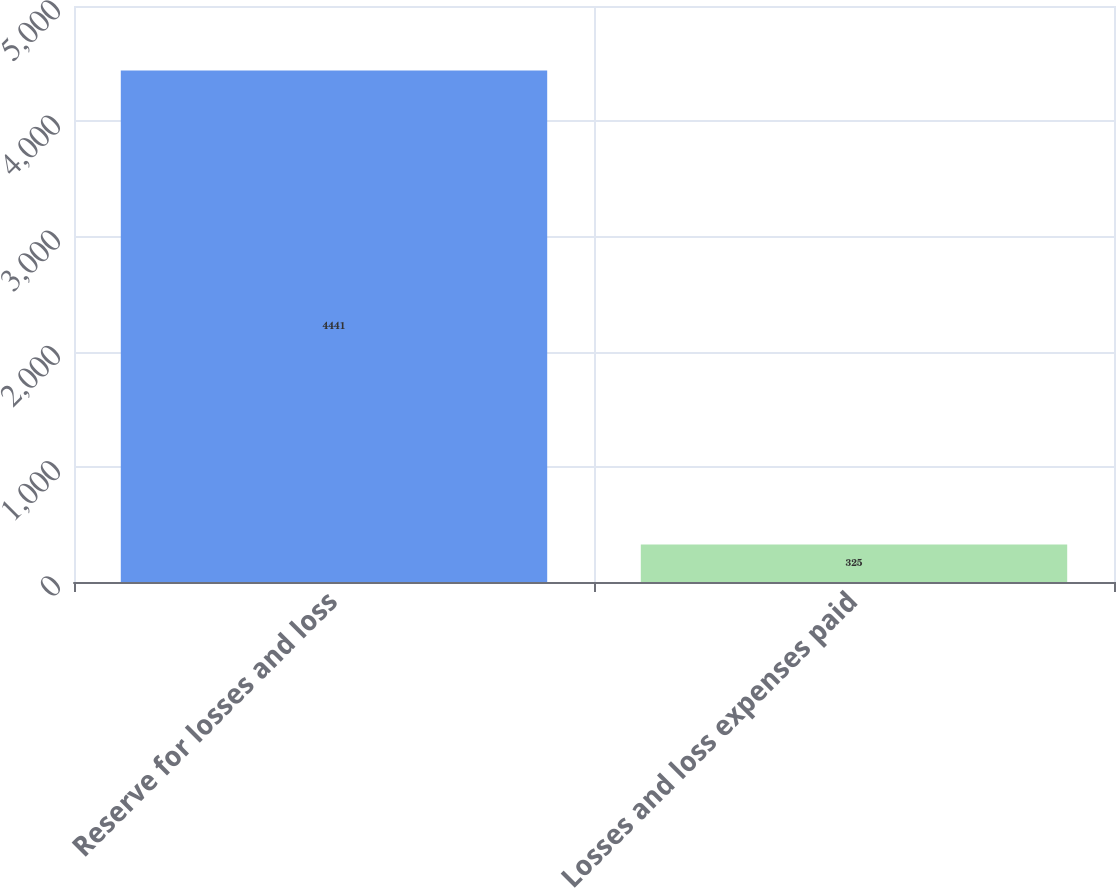<chart> <loc_0><loc_0><loc_500><loc_500><bar_chart><fcel>Reserve for losses and loss<fcel>Losses and loss expenses paid<nl><fcel>4441<fcel>325<nl></chart> 